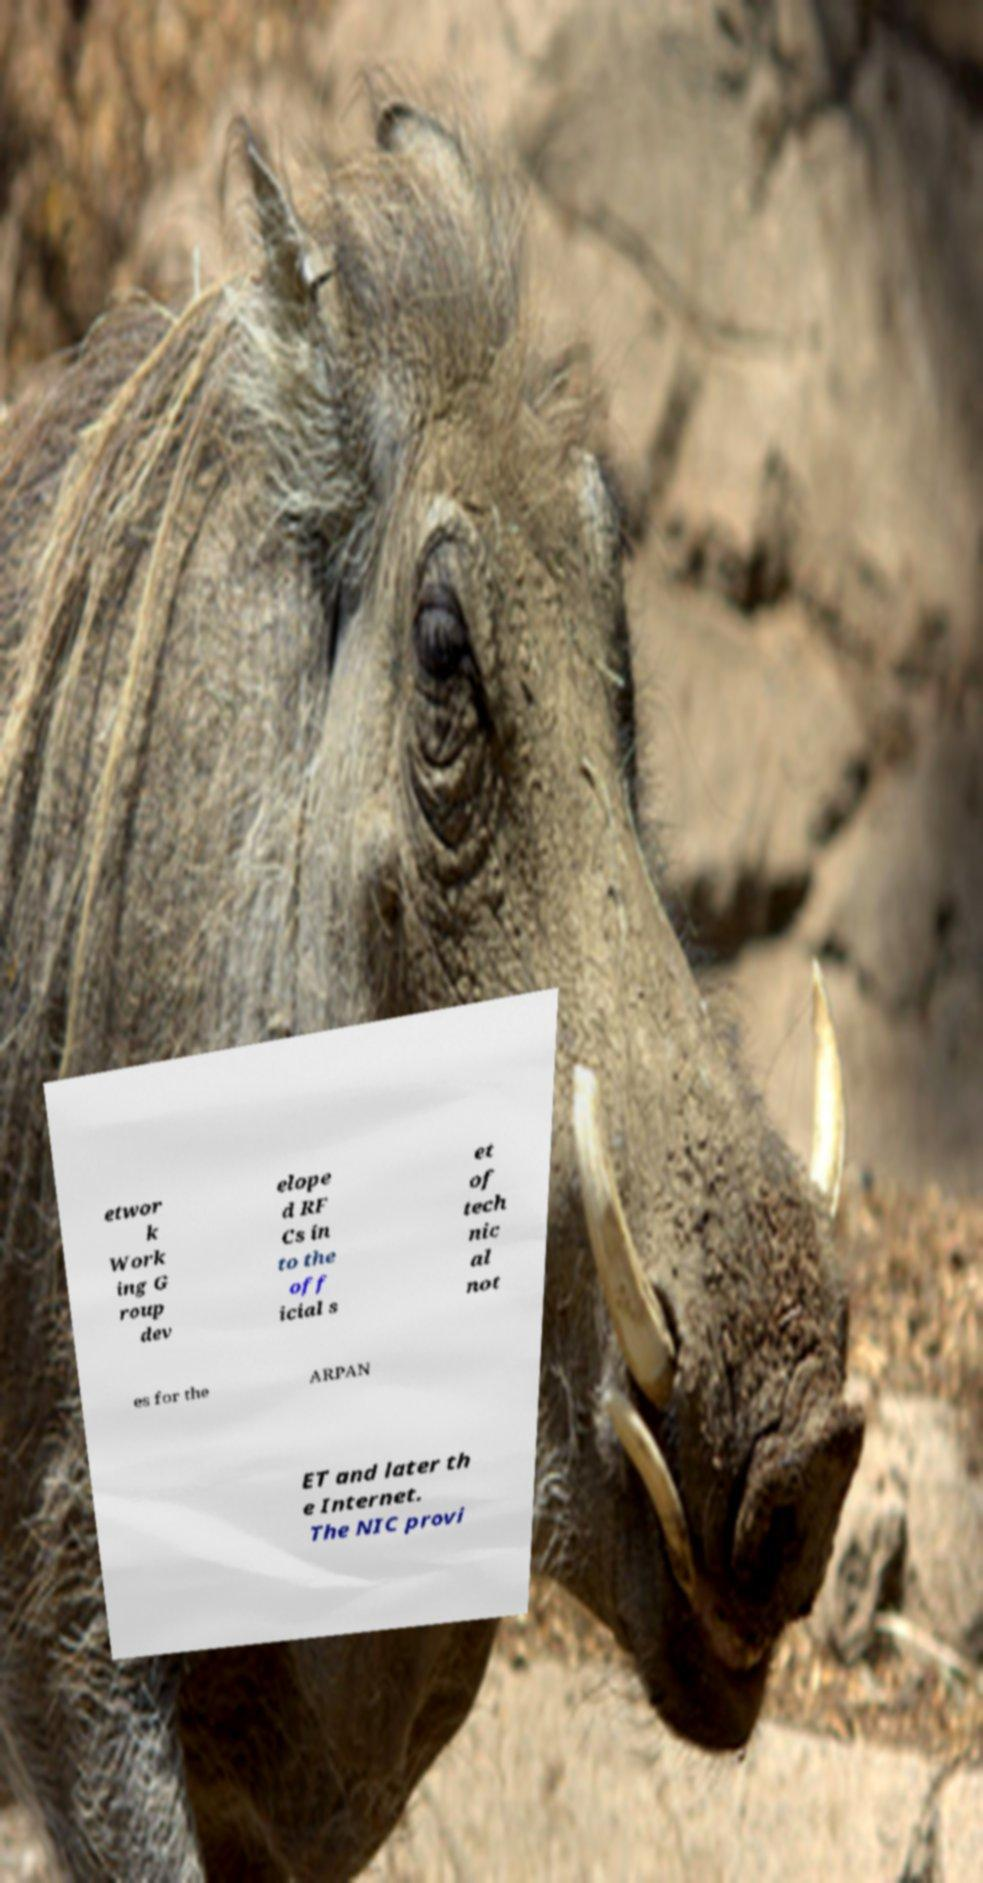I need the written content from this picture converted into text. Can you do that? etwor k Work ing G roup dev elope d RF Cs in to the off icial s et of tech nic al not es for the ARPAN ET and later th e Internet. The NIC provi 